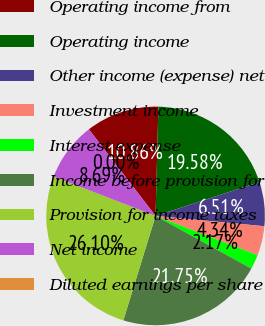Convert chart. <chart><loc_0><loc_0><loc_500><loc_500><pie_chart><fcel>Operating income from<fcel>Operating income<fcel>Other income (expense) net<fcel>Investment income<fcel>Interest expense<fcel>Income before provision for<fcel>Provision for income taxes<fcel>Net income<fcel>Diluted earnings per share<nl><fcel>10.86%<fcel>19.58%<fcel>6.51%<fcel>4.34%<fcel>2.17%<fcel>21.75%<fcel>26.1%<fcel>8.69%<fcel>0.0%<nl></chart> 